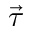Convert formula to latex. <formula><loc_0><loc_0><loc_500><loc_500>\vec { \tau }</formula> 